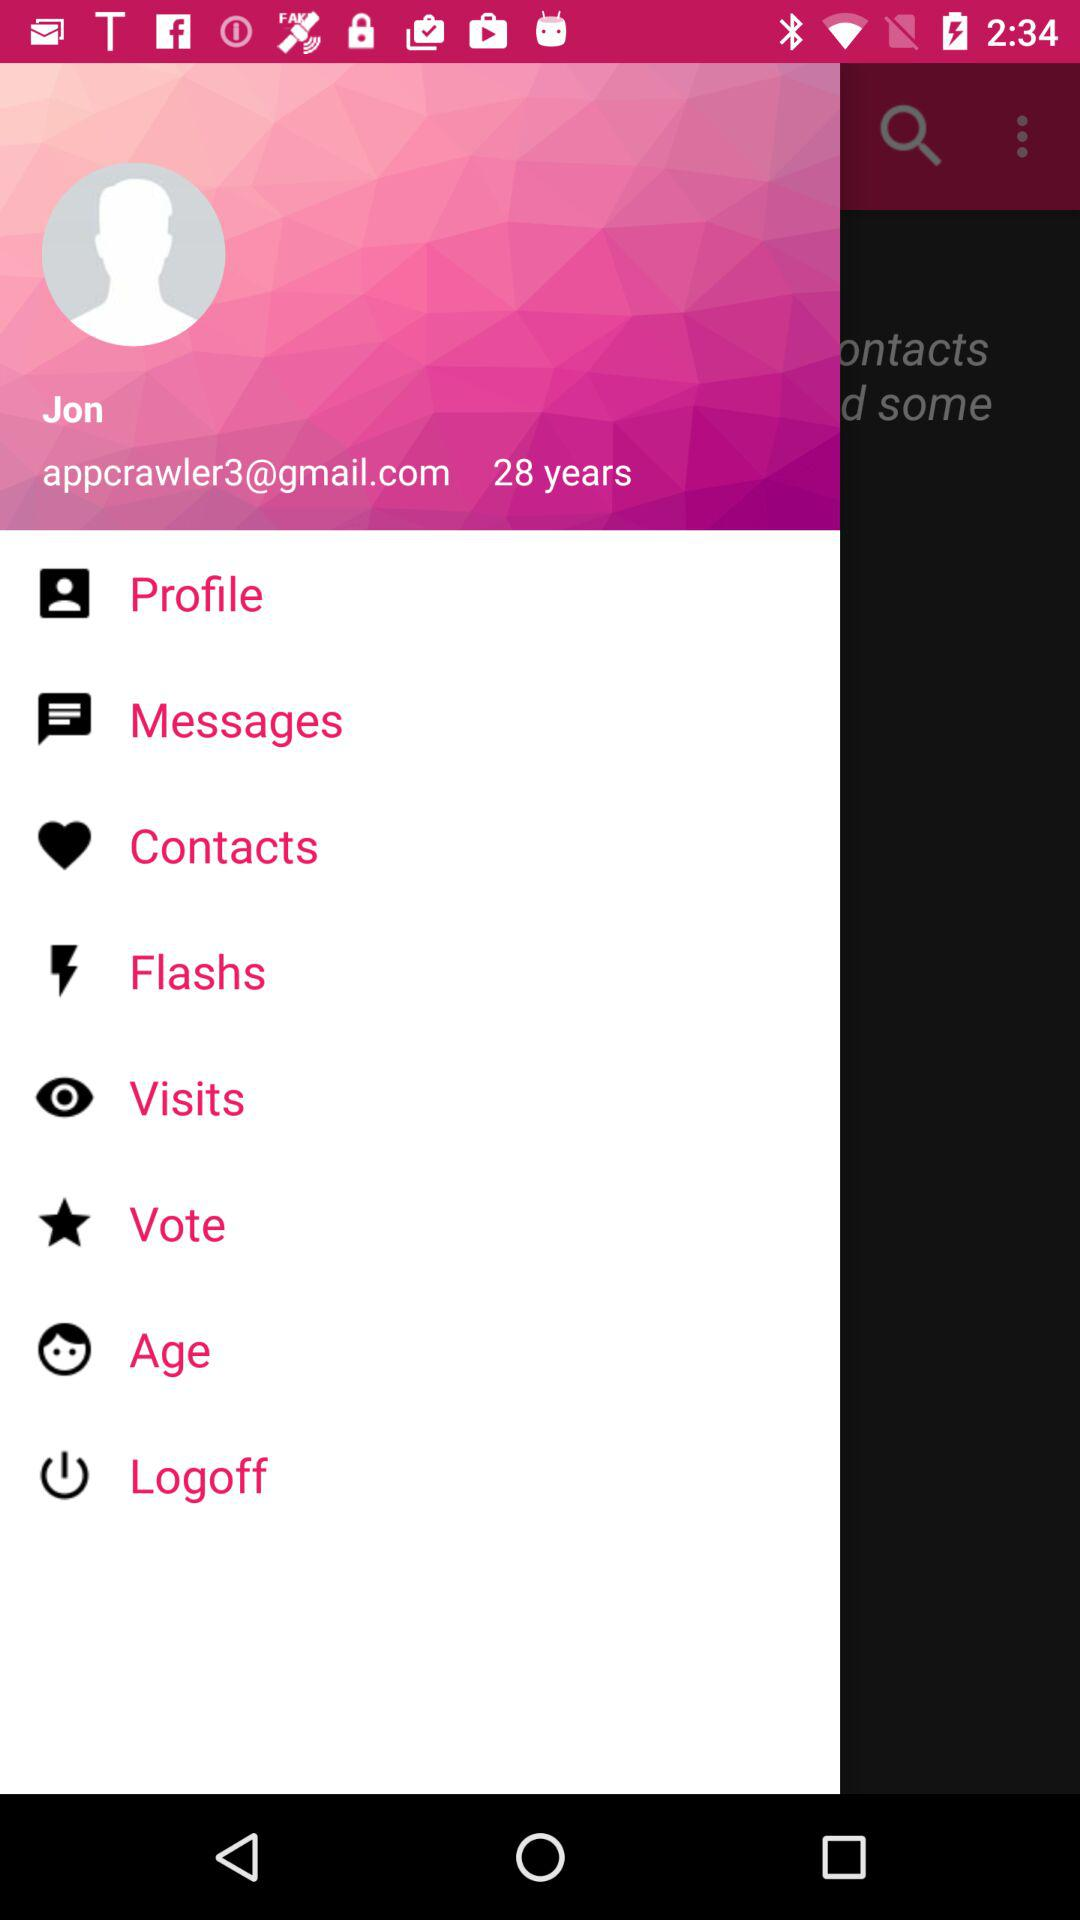What is the user name? The user name is Jon. 